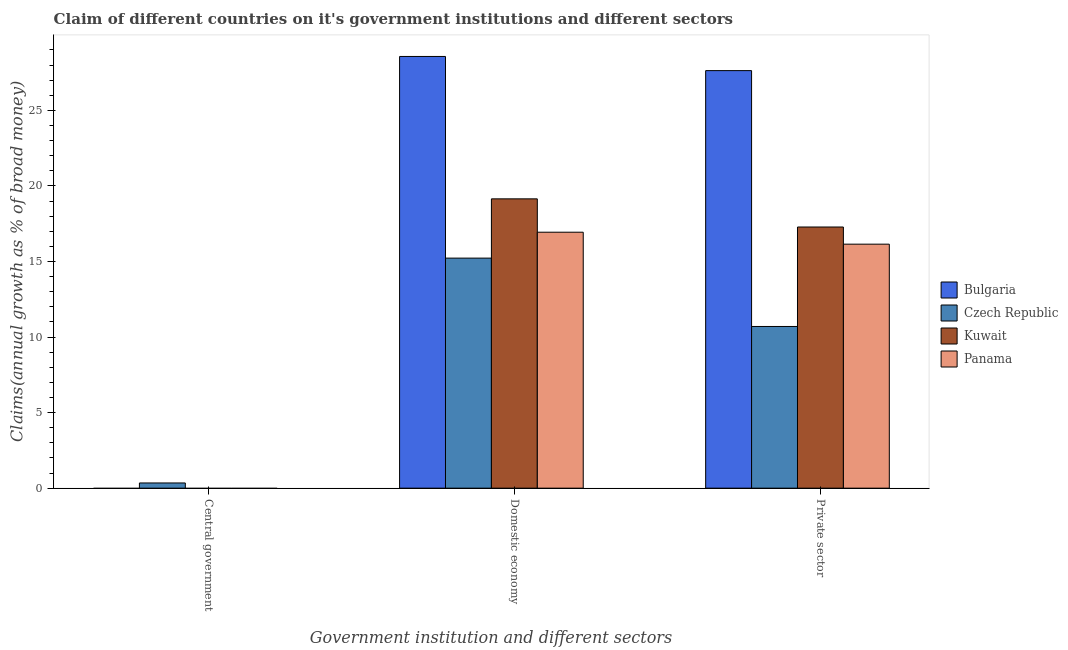Are the number of bars on each tick of the X-axis equal?
Your response must be concise. No. How many bars are there on the 2nd tick from the right?
Offer a very short reply. 4. What is the label of the 1st group of bars from the left?
Offer a very short reply. Central government. What is the percentage of claim on the central government in Czech Republic?
Give a very brief answer. 0.34. Across all countries, what is the maximum percentage of claim on the private sector?
Give a very brief answer. 27.63. Across all countries, what is the minimum percentage of claim on the domestic economy?
Offer a very short reply. 15.22. What is the total percentage of claim on the central government in the graph?
Your answer should be very brief. 0.34. What is the difference between the percentage of claim on the private sector in Bulgaria and that in Kuwait?
Your answer should be compact. 10.35. What is the difference between the percentage of claim on the domestic economy in Bulgaria and the percentage of claim on the private sector in Kuwait?
Keep it short and to the point. 11.29. What is the average percentage of claim on the private sector per country?
Your answer should be very brief. 17.94. What is the difference between the percentage of claim on the domestic economy and percentage of claim on the private sector in Bulgaria?
Make the answer very short. 0.94. In how many countries, is the percentage of claim on the central government greater than 4 %?
Keep it short and to the point. 0. What is the ratio of the percentage of claim on the private sector in Kuwait to that in Bulgaria?
Give a very brief answer. 0.63. Is the percentage of claim on the private sector in Bulgaria less than that in Czech Republic?
Keep it short and to the point. No. What is the difference between the highest and the second highest percentage of claim on the domestic economy?
Make the answer very short. 9.42. What is the difference between the highest and the lowest percentage of claim on the private sector?
Ensure brevity in your answer.  16.93. How many countries are there in the graph?
Provide a short and direct response. 4. What is the difference between two consecutive major ticks on the Y-axis?
Provide a succinct answer. 5. Are the values on the major ticks of Y-axis written in scientific E-notation?
Your answer should be very brief. No. Does the graph contain any zero values?
Make the answer very short. Yes. How many legend labels are there?
Provide a succinct answer. 4. How are the legend labels stacked?
Your answer should be compact. Vertical. What is the title of the graph?
Give a very brief answer. Claim of different countries on it's government institutions and different sectors. Does "High income: OECD" appear as one of the legend labels in the graph?
Offer a very short reply. No. What is the label or title of the X-axis?
Your answer should be very brief. Government institution and different sectors. What is the label or title of the Y-axis?
Keep it short and to the point. Claims(annual growth as % of broad money). What is the Claims(annual growth as % of broad money) in Bulgaria in Central government?
Give a very brief answer. 0. What is the Claims(annual growth as % of broad money) in Czech Republic in Central government?
Your response must be concise. 0.34. What is the Claims(annual growth as % of broad money) in Panama in Central government?
Offer a terse response. 0. What is the Claims(annual growth as % of broad money) of Bulgaria in Domestic economy?
Provide a succinct answer. 28.57. What is the Claims(annual growth as % of broad money) in Czech Republic in Domestic economy?
Provide a short and direct response. 15.22. What is the Claims(annual growth as % of broad money) of Kuwait in Domestic economy?
Provide a short and direct response. 19.15. What is the Claims(annual growth as % of broad money) of Panama in Domestic economy?
Keep it short and to the point. 16.94. What is the Claims(annual growth as % of broad money) in Bulgaria in Private sector?
Offer a terse response. 27.63. What is the Claims(annual growth as % of broad money) of Czech Republic in Private sector?
Give a very brief answer. 10.7. What is the Claims(annual growth as % of broad money) in Kuwait in Private sector?
Your response must be concise. 17.28. What is the Claims(annual growth as % of broad money) in Panama in Private sector?
Provide a short and direct response. 16.15. Across all Government institution and different sectors, what is the maximum Claims(annual growth as % of broad money) of Bulgaria?
Ensure brevity in your answer.  28.57. Across all Government institution and different sectors, what is the maximum Claims(annual growth as % of broad money) of Czech Republic?
Your response must be concise. 15.22. Across all Government institution and different sectors, what is the maximum Claims(annual growth as % of broad money) in Kuwait?
Make the answer very short. 19.15. Across all Government institution and different sectors, what is the maximum Claims(annual growth as % of broad money) of Panama?
Ensure brevity in your answer.  16.94. Across all Government institution and different sectors, what is the minimum Claims(annual growth as % of broad money) of Czech Republic?
Ensure brevity in your answer.  0.34. What is the total Claims(annual growth as % of broad money) of Bulgaria in the graph?
Your response must be concise. 56.2. What is the total Claims(annual growth as % of broad money) in Czech Republic in the graph?
Your answer should be very brief. 26.27. What is the total Claims(annual growth as % of broad money) in Kuwait in the graph?
Ensure brevity in your answer.  36.43. What is the total Claims(annual growth as % of broad money) of Panama in the graph?
Your answer should be compact. 33.09. What is the difference between the Claims(annual growth as % of broad money) of Czech Republic in Central government and that in Domestic economy?
Make the answer very short. -14.88. What is the difference between the Claims(annual growth as % of broad money) in Czech Republic in Central government and that in Private sector?
Your response must be concise. -10.36. What is the difference between the Claims(annual growth as % of broad money) of Bulgaria in Domestic economy and that in Private sector?
Your answer should be compact. 0.94. What is the difference between the Claims(annual growth as % of broad money) in Czech Republic in Domestic economy and that in Private sector?
Provide a succinct answer. 4.52. What is the difference between the Claims(annual growth as % of broad money) of Kuwait in Domestic economy and that in Private sector?
Keep it short and to the point. 1.86. What is the difference between the Claims(annual growth as % of broad money) of Panama in Domestic economy and that in Private sector?
Offer a terse response. 0.79. What is the difference between the Claims(annual growth as % of broad money) in Czech Republic in Central government and the Claims(annual growth as % of broad money) in Kuwait in Domestic economy?
Provide a short and direct response. -18.8. What is the difference between the Claims(annual growth as % of broad money) of Czech Republic in Central government and the Claims(annual growth as % of broad money) of Panama in Domestic economy?
Ensure brevity in your answer.  -16.59. What is the difference between the Claims(annual growth as % of broad money) in Czech Republic in Central government and the Claims(annual growth as % of broad money) in Kuwait in Private sector?
Ensure brevity in your answer.  -16.94. What is the difference between the Claims(annual growth as % of broad money) in Czech Republic in Central government and the Claims(annual growth as % of broad money) in Panama in Private sector?
Offer a terse response. -15.8. What is the difference between the Claims(annual growth as % of broad money) in Bulgaria in Domestic economy and the Claims(annual growth as % of broad money) in Czech Republic in Private sector?
Provide a short and direct response. 17.87. What is the difference between the Claims(annual growth as % of broad money) of Bulgaria in Domestic economy and the Claims(annual growth as % of broad money) of Kuwait in Private sector?
Keep it short and to the point. 11.29. What is the difference between the Claims(annual growth as % of broad money) of Bulgaria in Domestic economy and the Claims(annual growth as % of broad money) of Panama in Private sector?
Keep it short and to the point. 12.42. What is the difference between the Claims(annual growth as % of broad money) in Czech Republic in Domestic economy and the Claims(annual growth as % of broad money) in Kuwait in Private sector?
Make the answer very short. -2.06. What is the difference between the Claims(annual growth as % of broad money) of Czech Republic in Domestic economy and the Claims(annual growth as % of broad money) of Panama in Private sector?
Ensure brevity in your answer.  -0.92. What is the difference between the Claims(annual growth as % of broad money) in Kuwait in Domestic economy and the Claims(annual growth as % of broad money) in Panama in Private sector?
Ensure brevity in your answer.  3. What is the average Claims(annual growth as % of broad money) in Bulgaria per Government institution and different sectors?
Your answer should be compact. 18.73. What is the average Claims(annual growth as % of broad money) of Czech Republic per Government institution and different sectors?
Make the answer very short. 8.76. What is the average Claims(annual growth as % of broad money) of Kuwait per Government institution and different sectors?
Provide a short and direct response. 12.14. What is the average Claims(annual growth as % of broad money) of Panama per Government institution and different sectors?
Give a very brief answer. 11.03. What is the difference between the Claims(annual growth as % of broad money) of Bulgaria and Claims(annual growth as % of broad money) of Czech Republic in Domestic economy?
Provide a succinct answer. 13.35. What is the difference between the Claims(annual growth as % of broad money) of Bulgaria and Claims(annual growth as % of broad money) of Kuwait in Domestic economy?
Your answer should be very brief. 9.42. What is the difference between the Claims(annual growth as % of broad money) in Bulgaria and Claims(annual growth as % of broad money) in Panama in Domestic economy?
Provide a short and direct response. 11.63. What is the difference between the Claims(annual growth as % of broad money) in Czech Republic and Claims(annual growth as % of broad money) in Kuwait in Domestic economy?
Keep it short and to the point. -3.92. What is the difference between the Claims(annual growth as % of broad money) in Czech Republic and Claims(annual growth as % of broad money) in Panama in Domestic economy?
Make the answer very short. -1.71. What is the difference between the Claims(annual growth as % of broad money) in Kuwait and Claims(annual growth as % of broad money) in Panama in Domestic economy?
Provide a succinct answer. 2.21. What is the difference between the Claims(annual growth as % of broad money) of Bulgaria and Claims(annual growth as % of broad money) of Czech Republic in Private sector?
Give a very brief answer. 16.93. What is the difference between the Claims(annual growth as % of broad money) of Bulgaria and Claims(annual growth as % of broad money) of Kuwait in Private sector?
Ensure brevity in your answer.  10.35. What is the difference between the Claims(annual growth as % of broad money) of Bulgaria and Claims(annual growth as % of broad money) of Panama in Private sector?
Provide a succinct answer. 11.49. What is the difference between the Claims(annual growth as % of broad money) in Czech Republic and Claims(annual growth as % of broad money) in Kuwait in Private sector?
Keep it short and to the point. -6.58. What is the difference between the Claims(annual growth as % of broad money) in Czech Republic and Claims(annual growth as % of broad money) in Panama in Private sector?
Provide a succinct answer. -5.45. What is the difference between the Claims(annual growth as % of broad money) of Kuwait and Claims(annual growth as % of broad money) of Panama in Private sector?
Offer a very short reply. 1.14. What is the ratio of the Claims(annual growth as % of broad money) in Czech Republic in Central government to that in Domestic economy?
Keep it short and to the point. 0.02. What is the ratio of the Claims(annual growth as % of broad money) in Czech Republic in Central government to that in Private sector?
Your response must be concise. 0.03. What is the ratio of the Claims(annual growth as % of broad money) in Bulgaria in Domestic economy to that in Private sector?
Ensure brevity in your answer.  1.03. What is the ratio of the Claims(annual growth as % of broad money) of Czech Republic in Domestic economy to that in Private sector?
Give a very brief answer. 1.42. What is the ratio of the Claims(annual growth as % of broad money) of Kuwait in Domestic economy to that in Private sector?
Provide a short and direct response. 1.11. What is the ratio of the Claims(annual growth as % of broad money) of Panama in Domestic economy to that in Private sector?
Your answer should be compact. 1.05. What is the difference between the highest and the second highest Claims(annual growth as % of broad money) of Czech Republic?
Your response must be concise. 4.52. What is the difference between the highest and the lowest Claims(annual growth as % of broad money) of Bulgaria?
Your answer should be very brief. 28.57. What is the difference between the highest and the lowest Claims(annual growth as % of broad money) in Czech Republic?
Your answer should be very brief. 14.88. What is the difference between the highest and the lowest Claims(annual growth as % of broad money) of Kuwait?
Your response must be concise. 19.15. What is the difference between the highest and the lowest Claims(annual growth as % of broad money) of Panama?
Provide a short and direct response. 16.94. 